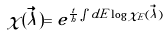Convert formula to latex. <formula><loc_0><loc_0><loc_500><loc_500>\chi ( \vec { \lambda } ) = e ^ { \frac { t } { h } \int d E \log { \chi _ { E } ( \vec { \lambda } ) } }</formula> 